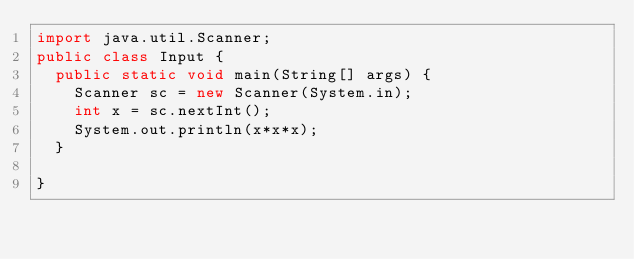Convert code to text. <code><loc_0><loc_0><loc_500><loc_500><_Java_>import java.util.Scanner;
public class Input {
	public static void main(String[] args) {
		Scanner sc = new Scanner(System.in);
		int x = sc.nextInt();
		System.out.println(x*x*x);
	}

}</code> 